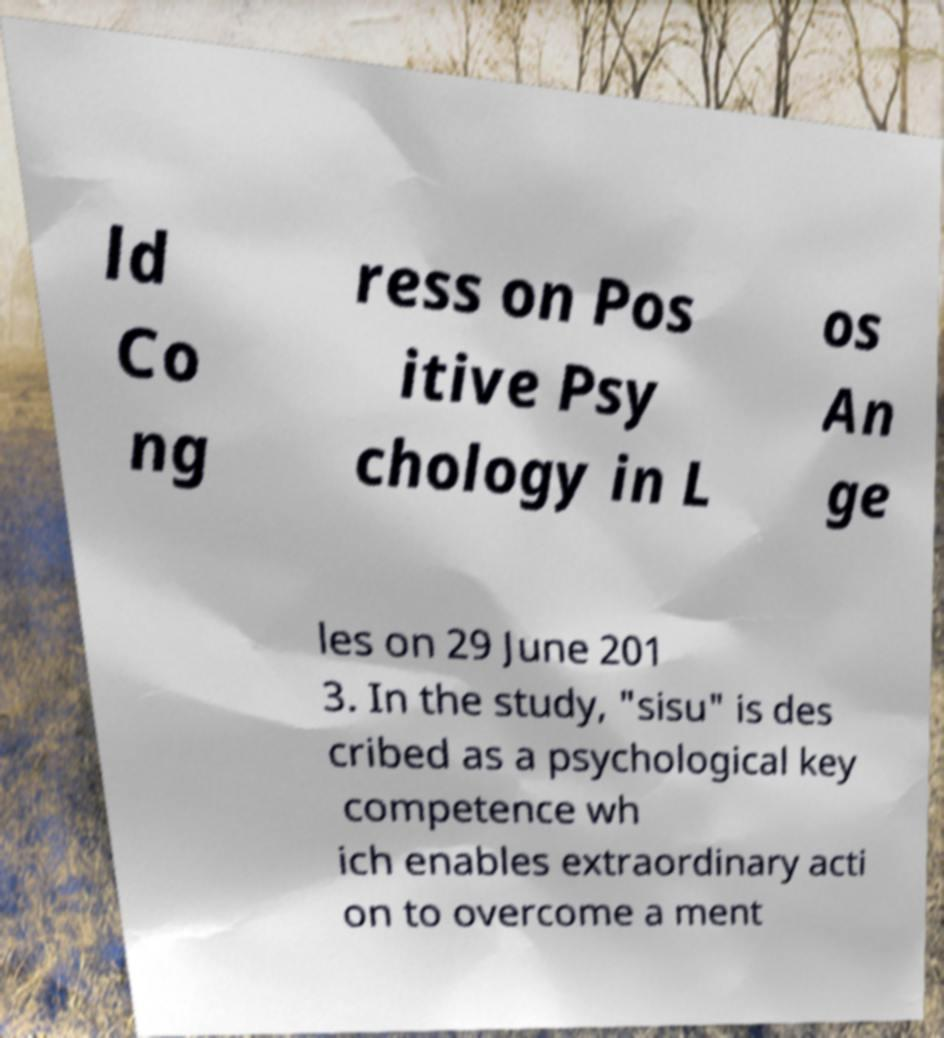Please read and relay the text visible in this image. What does it say? ld Co ng ress on Pos itive Psy chology in L os An ge les on 29 June 201 3. In the study, "sisu" is des cribed as a psychological key competence wh ich enables extraordinary acti on to overcome a ment 